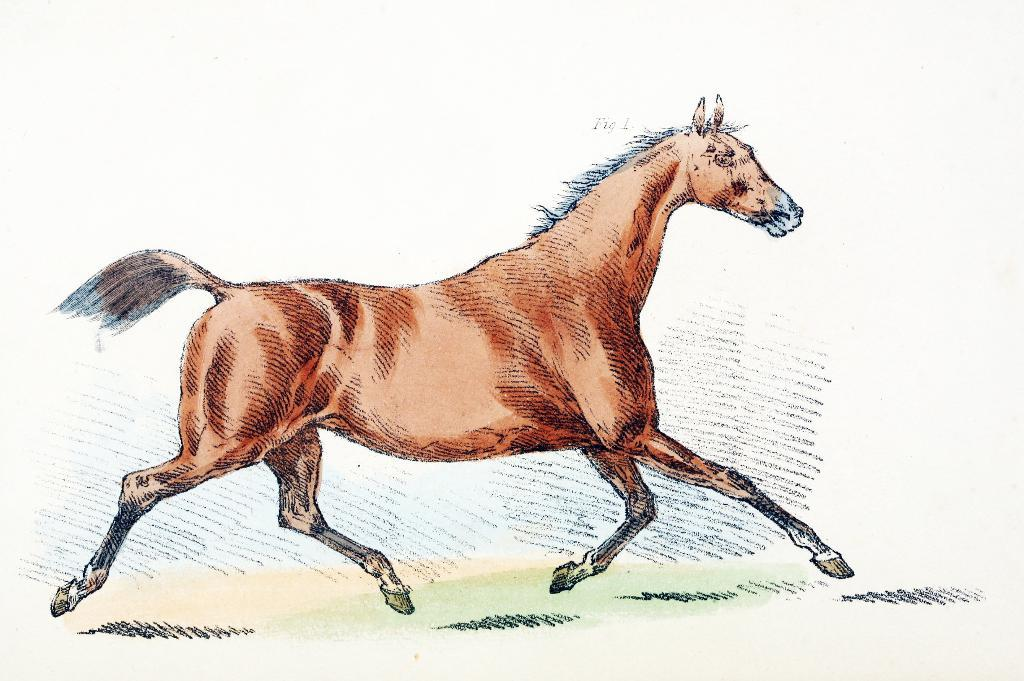What is featured in the image? There is a poster in the image. What is depicted on the poster? The poster contains a picture of a horse. What type of cub can be seen playing with a paper and twig in the image? There is no cub, paper, or twig present in the image; it only features a poster with a picture of a horse. 